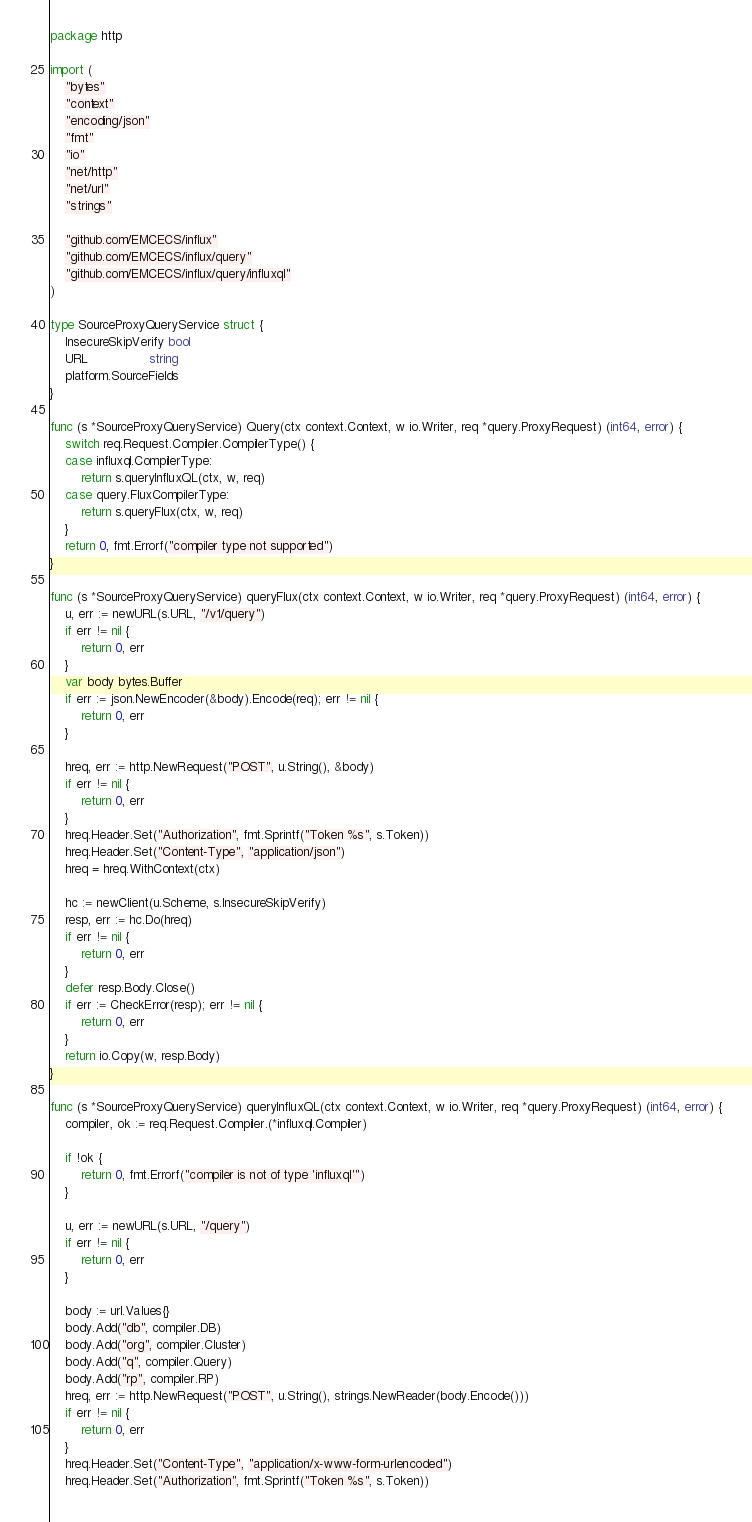Convert code to text. <code><loc_0><loc_0><loc_500><loc_500><_Go_>package http

import (
	"bytes"
	"context"
	"encoding/json"
	"fmt"
	"io"
	"net/http"
	"net/url"
	"strings"

	"github.com/EMCECS/influx"
	"github.com/EMCECS/influx/query"
	"github.com/EMCECS/influx/query/influxql"
)

type SourceProxyQueryService struct {
	InsecureSkipVerify bool
	URL                string
	platform.SourceFields
}

func (s *SourceProxyQueryService) Query(ctx context.Context, w io.Writer, req *query.ProxyRequest) (int64, error) {
	switch req.Request.Compiler.CompilerType() {
	case influxql.CompilerType:
		return s.queryInfluxQL(ctx, w, req)
	case query.FluxCompilerType:
		return s.queryFlux(ctx, w, req)
	}
	return 0, fmt.Errorf("compiler type not supported")
}

func (s *SourceProxyQueryService) queryFlux(ctx context.Context, w io.Writer, req *query.ProxyRequest) (int64, error) {
	u, err := newURL(s.URL, "/v1/query")
	if err != nil {
		return 0, err
	}
	var body bytes.Buffer
	if err := json.NewEncoder(&body).Encode(req); err != nil {
		return 0, err
	}

	hreq, err := http.NewRequest("POST", u.String(), &body)
	if err != nil {
		return 0, err
	}
	hreq.Header.Set("Authorization", fmt.Sprintf("Token %s", s.Token))
	hreq.Header.Set("Content-Type", "application/json")
	hreq = hreq.WithContext(ctx)

	hc := newClient(u.Scheme, s.InsecureSkipVerify)
	resp, err := hc.Do(hreq)
	if err != nil {
		return 0, err
	}
	defer resp.Body.Close()
	if err := CheckError(resp); err != nil {
		return 0, err
	}
	return io.Copy(w, resp.Body)
}

func (s *SourceProxyQueryService) queryInfluxQL(ctx context.Context, w io.Writer, req *query.ProxyRequest) (int64, error) {
	compiler, ok := req.Request.Compiler.(*influxql.Compiler)

	if !ok {
		return 0, fmt.Errorf("compiler is not of type 'influxql'")
	}

	u, err := newURL(s.URL, "/query")
	if err != nil {
		return 0, err
	}

	body := url.Values{}
	body.Add("db", compiler.DB)
	body.Add("org", compiler.Cluster)
	body.Add("q", compiler.Query)
	body.Add("rp", compiler.RP)
	hreq, err := http.NewRequest("POST", u.String(), strings.NewReader(body.Encode()))
	if err != nil {
		return 0, err
	}
	hreq.Header.Set("Content-Type", "application/x-www-form-urlencoded")
	hreq.Header.Set("Authorization", fmt.Sprintf("Token %s", s.Token))</code> 